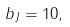Convert formula to latex. <formula><loc_0><loc_0><loc_500><loc_500>b _ { J } = 1 0 ,</formula> 